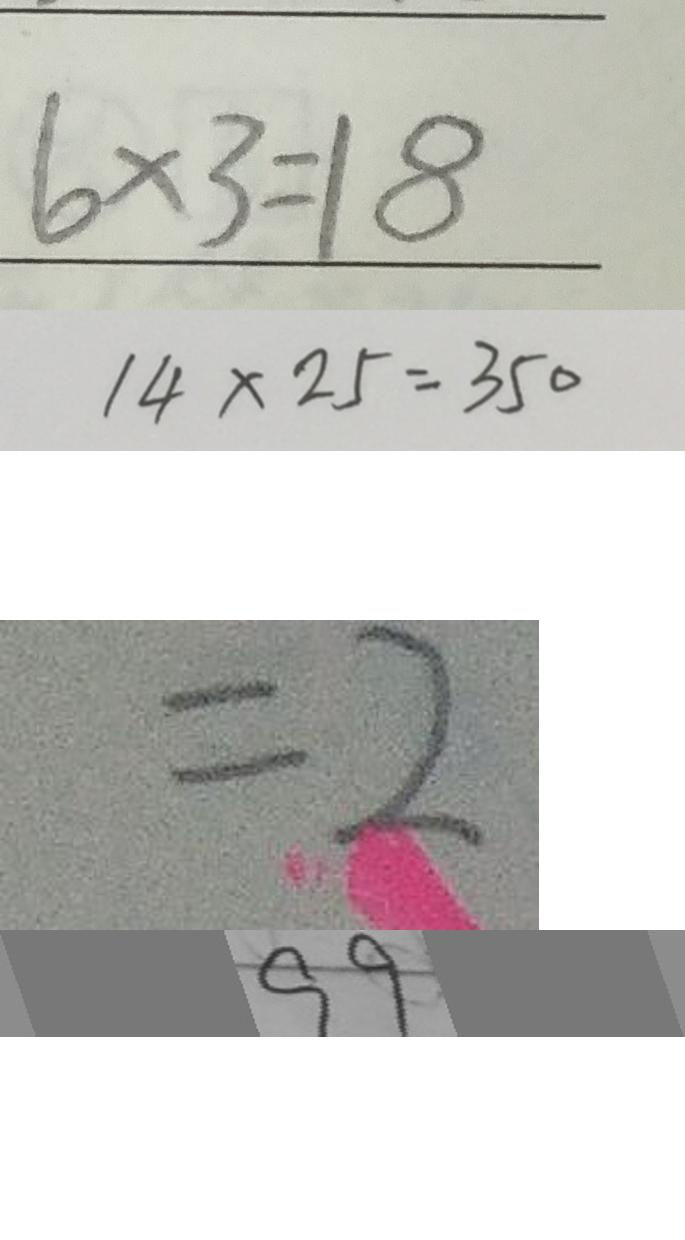<formula> <loc_0><loc_0><loc_500><loc_500>6 \times 3 = 1 8 
 1 4 \times 2 5 = 3 5 0 
 = 2 
 9 9</formula> 